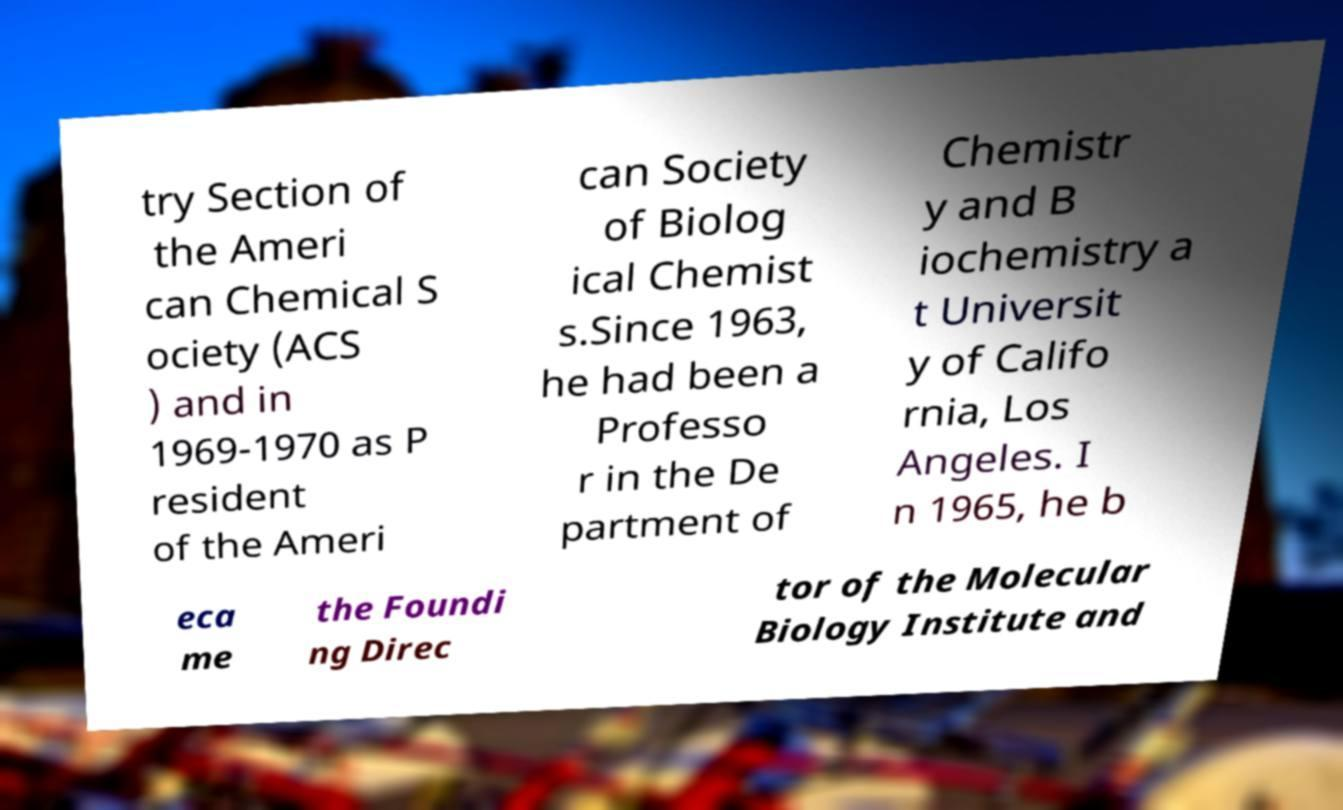For documentation purposes, I need the text within this image transcribed. Could you provide that? try Section of the Ameri can Chemical S ociety (ACS ) and in 1969-1970 as P resident of the Ameri can Society of Biolog ical Chemist s.Since 1963, he had been a Professo r in the De partment of Chemistr y and B iochemistry a t Universit y of Califo rnia, Los Angeles. I n 1965, he b eca me the Foundi ng Direc tor of the Molecular Biology Institute and 